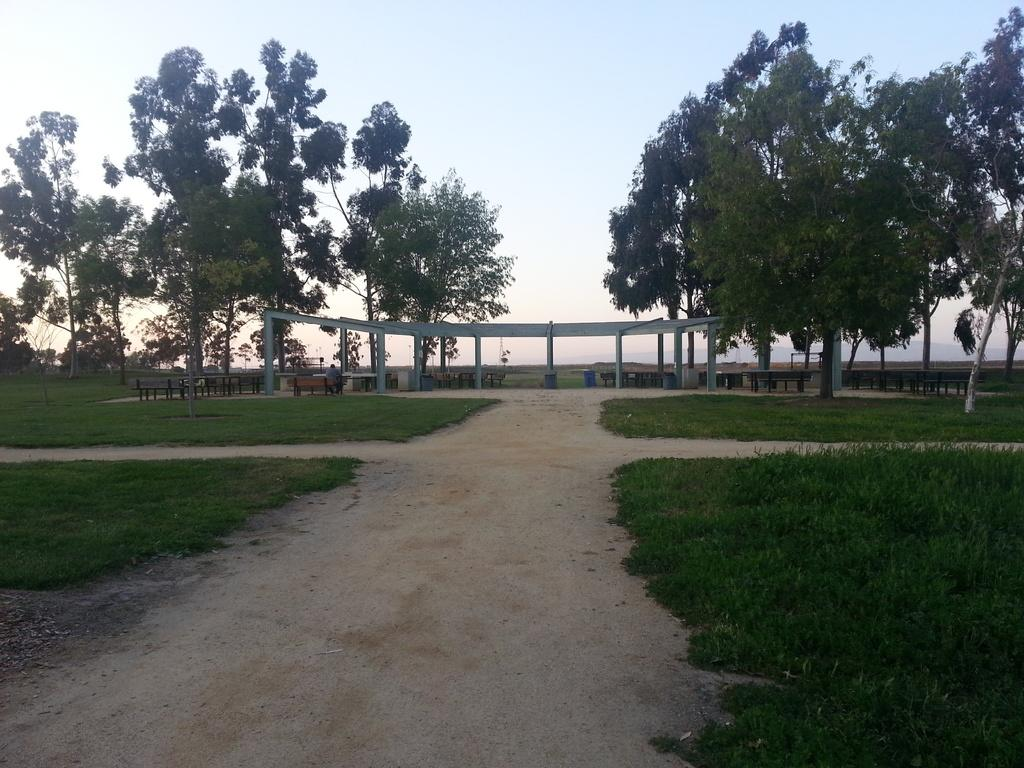How many benches can be seen in the image? There are many benches in the image. What is the person in the image doing? A person is sitting on one of the benches. What type of structure is present in the image? There is a pole tent in the image. What type of ground surface is visible in the image? Grass is present in the image. What type of path is visible in the image? There is a path in the image. What type of vegetation is visible in the image? Trees are visible in the image. What part of the natural environment is visible in the image? The sky is visible in the image. Can you describe the tail of the animal in the image? There is no animal with a tail present in the image. What is the reaction of the person to the sudden noise in the image? There is no sudden noise or reaction mentioned in the image. 